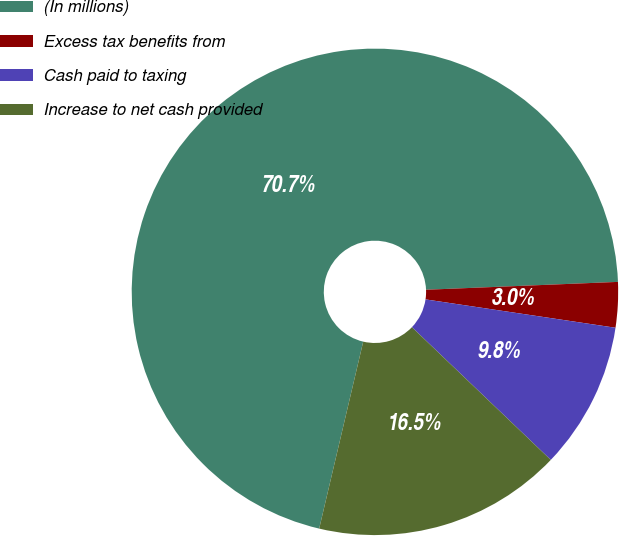Convert chart to OTSL. <chart><loc_0><loc_0><loc_500><loc_500><pie_chart><fcel>(In millions)<fcel>Excess tax benefits from<fcel>Cash paid to taxing<fcel>Increase to net cash provided<nl><fcel>70.66%<fcel>3.01%<fcel>9.78%<fcel>16.54%<nl></chart> 